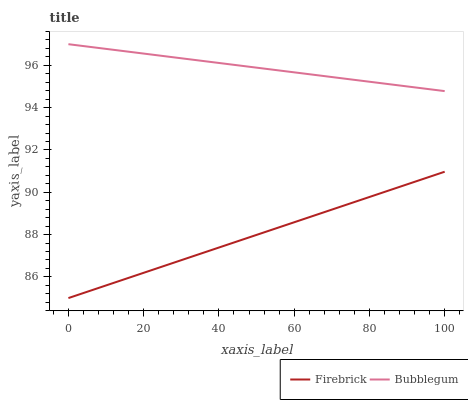Does Firebrick have the minimum area under the curve?
Answer yes or no. Yes. Does Bubblegum have the maximum area under the curve?
Answer yes or no. Yes. Does Bubblegum have the minimum area under the curve?
Answer yes or no. No. Is Firebrick the smoothest?
Answer yes or no. Yes. Is Bubblegum the roughest?
Answer yes or no. Yes. Is Bubblegum the smoothest?
Answer yes or no. No. Does Firebrick have the lowest value?
Answer yes or no. Yes. Does Bubblegum have the lowest value?
Answer yes or no. No. Does Bubblegum have the highest value?
Answer yes or no. Yes. Is Firebrick less than Bubblegum?
Answer yes or no. Yes. Is Bubblegum greater than Firebrick?
Answer yes or no. Yes. Does Firebrick intersect Bubblegum?
Answer yes or no. No. 